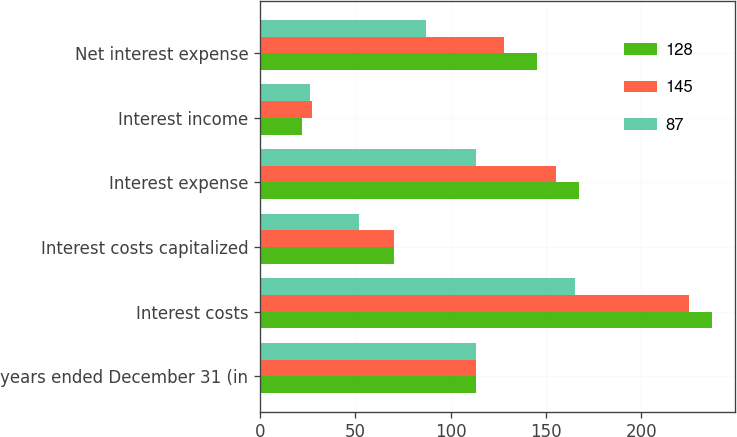<chart> <loc_0><loc_0><loc_500><loc_500><stacked_bar_chart><ecel><fcel>years ended December 31 (in<fcel>Interest costs<fcel>Interest costs capitalized<fcel>Interest expense<fcel>Interest income<fcel>Net interest expense<nl><fcel>128<fcel>113<fcel>237<fcel>70<fcel>167<fcel>22<fcel>145<nl><fcel>145<fcel>113<fcel>225<fcel>70<fcel>155<fcel>27<fcel>128<nl><fcel>87<fcel>113<fcel>165<fcel>52<fcel>113<fcel>26<fcel>87<nl></chart> 